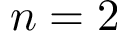<formula> <loc_0><loc_0><loc_500><loc_500>n = 2</formula> 